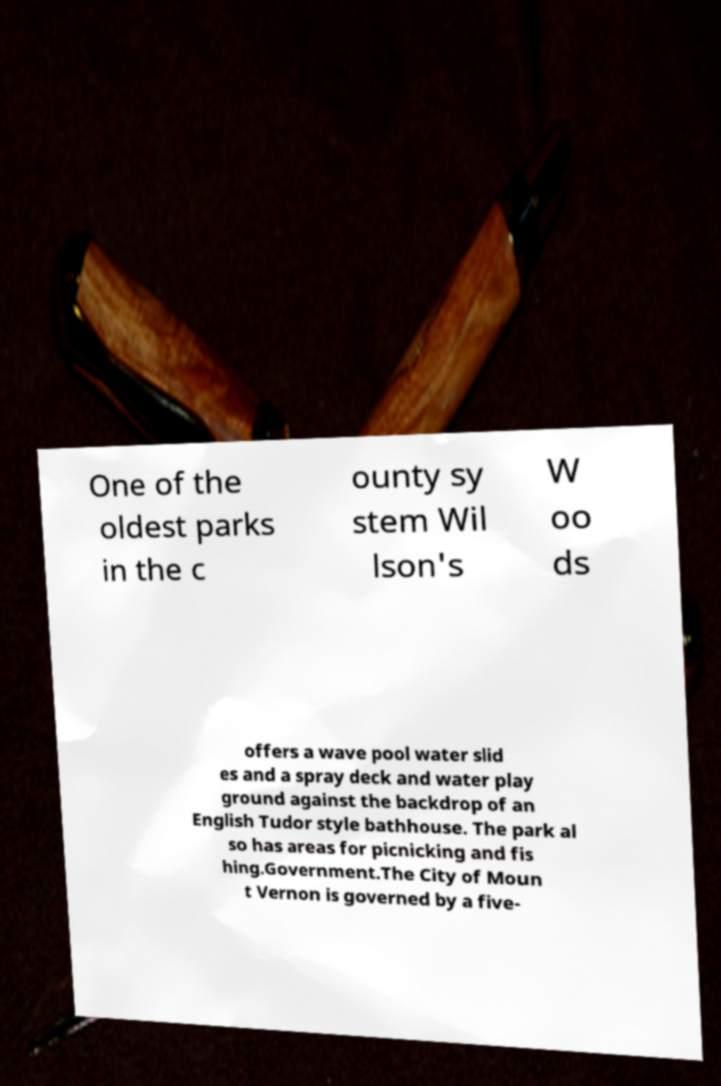What messages or text are displayed in this image? I need them in a readable, typed format. One of the oldest parks in the c ounty sy stem Wil lson's W oo ds offers a wave pool water slid es and a spray deck and water play ground against the backdrop of an English Tudor style bathhouse. The park al so has areas for picnicking and fis hing.Government.The City of Moun t Vernon is governed by a five- 